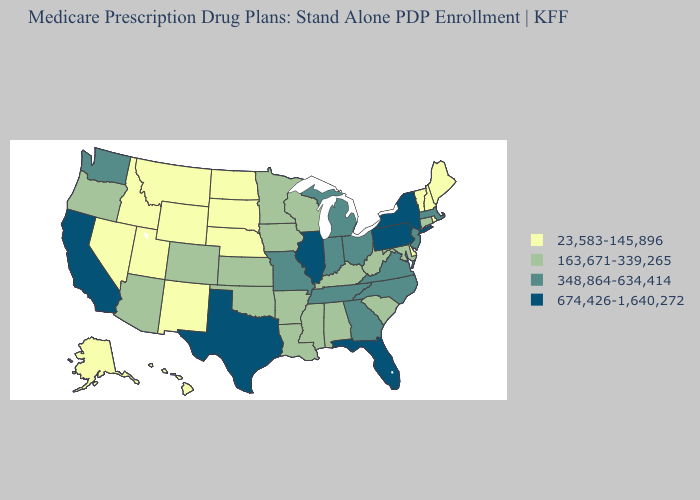Name the states that have a value in the range 674,426-1,640,272?
Give a very brief answer. California, Florida, Illinois, New York, Pennsylvania, Texas. What is the highest value in states that border South Carolina?
Be succinct. 348,864-634,414. Name the states that have a value in the range 674,426-1,640,272?
Be succinct. California, Florida, Illinois, New York, Pennsylvania, Texas. Is the legend a continuous bar?
Be succinct. No. What is the lowest value in states that border Alabama?
Keep it brief. 163,671-339,265. Name the states that have a value in the range 348,864-634,414?
Give a very brief answer. Georgia, Indiana, Massachusetts, Michigan, Missouri, North Carolina, New Jersey, Ohio, Tennessee, Virginia, Washington. What is the lowest value in the West?
Quick response, please. 23,583-145,896. Among the states that border Pennsylvania , which have the highest value?
Write a very short answer. New York. Name the states that have a value in the range 348,864-634,414?
Give a very brief answer. Georgia, Indiana, Massachusetts, Michigan, Missouri, North Carolina, New Jersey, Ohio, Tennessee, Virginia, Washington. What is the lowest value in states that border Missouri?
Short answer required. 23,583-145,896. What is the value of Rhode Island?
Give a very brief answer. 23,583-145,896. How many symbols are there in the legend?
Answer briefly. 4. What is the value of New Mexico?
Concise answer only. 23,583-145,896. Among the states that border Texas , which have the highest value?
Write a very short answer. Arkansas, Louisiana, Oklahoma. Does New Mexico have the lowest value in the West?
Concise answer only. Yes. 